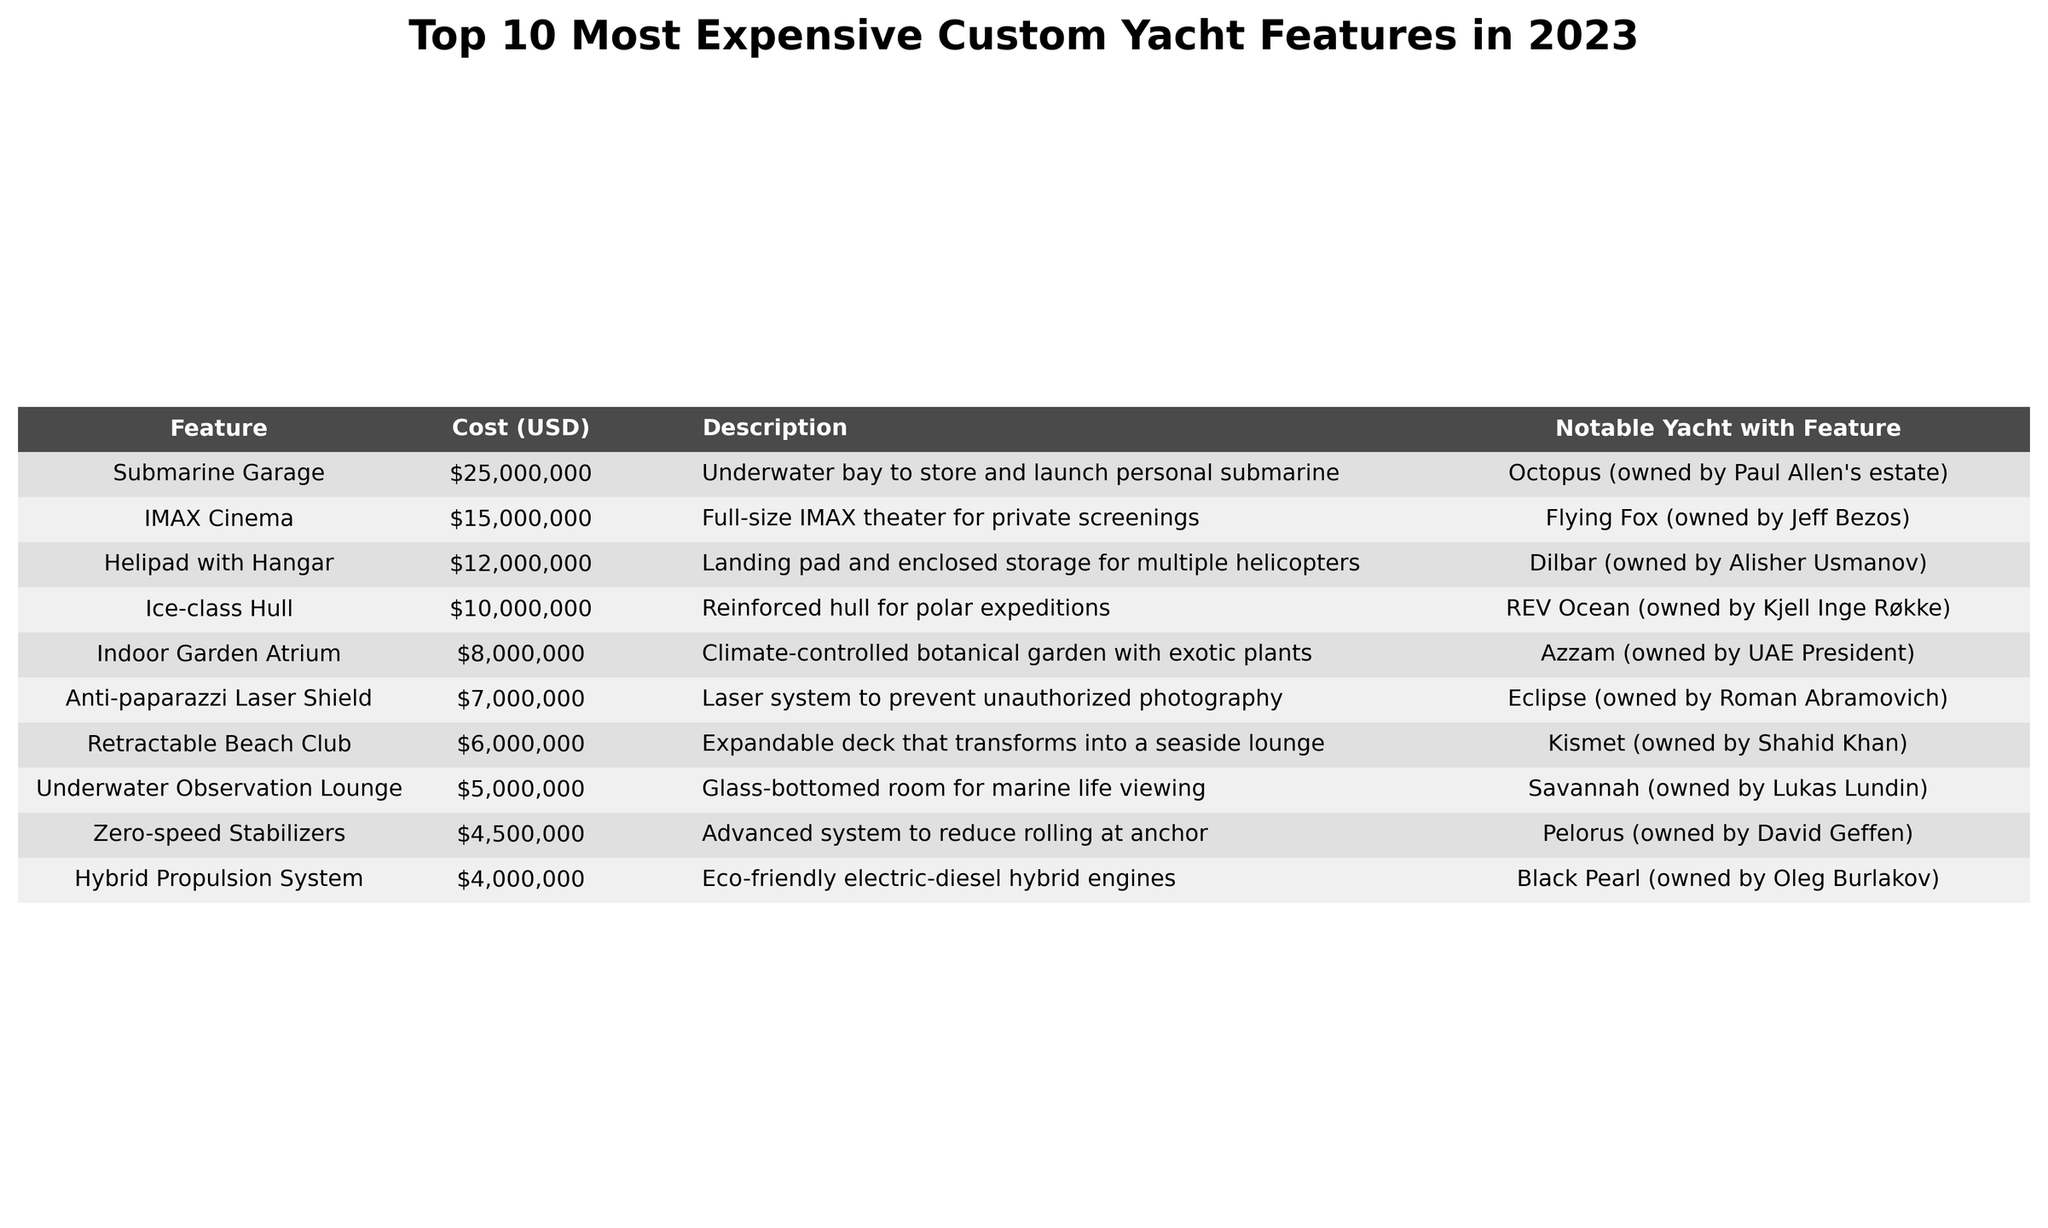What is the most expensive custom yacht feature in 2023? The table lists custom yacht features along with their costs, and the highest cost is $25,000,000 for a Submarine Garage.
Answer: Submarine Garage How much does the IMAX Cinema feature cost? Referring to the table, the cost for the IMAX Cinema feature is listed as $15,000,000.
Answer: $15,000,000 Which yacht has a Helipad with Hangar? The table shows that the yacht Dilbar has the Helipad with Hangar feature.
Answer: Dilbar Is the cost of the Anti-paparazzi Laser Shield greater than the cost of the Zero-speed Stabilizers? The cost of the Anti-paparazzi Laser Shield is $7,000,000, and the Zero-speed Stabilizers cost $4,500,000. Since $7,000,000 is greater than $4,500,000, the statement is true.
Answer: Yes What is the total cost of the features listed for Hybrid Propulsion System and Retractable Beach Club? The Hybrid Propulsion System costs $4,000,000 and the Retractable Beach Club costs $6,000,000. Adding these together gives $4,000,000 + $6,000,000 = $10,000,000.
Answer: $10,000,000 Which yacht features an Indoor Garden Atrium? The table states that the yacht Azzam features an Indoor Garden Atrium.
Answer: Azzam What is the difference in cost between the Ice-class Hull and the Indoor Garden Atrium? The Ice-class Hull costs $10,000,000 and the Indoor Garden Atrium costs $8,000,000. The difference is $10,000,000 - $8,000,000 = $2,000,000.
Answer: $2,000,000 Are there any features listed that cost more than $20,000,000? The table shows that the highest cost is $25,000,000, which is for the Submarine Garage, indicating that there is one feature over $20,000,000.
Answer: Yes How many features in the table are below $5,000,000? There is one feature, the Hybrid Propulsion System, which costs $4,000,000. Since only one feature is below $5,000,000, the answer is one.
Answer: 1 What is the average cost of the top three most expensive features? The top three features are Submarine Garage ($25,000,000), IMAX Cinema ($15,000,000), and Helipad with Hangar ($12,000,000). Their total cost is $25,000,000 + $15,000,000 + $12,000,000 = $52,000,000, and the average cost is $52,000,000 / 3 = $17,333,333.33 (rounded).
Answer: $17,333,333.33 